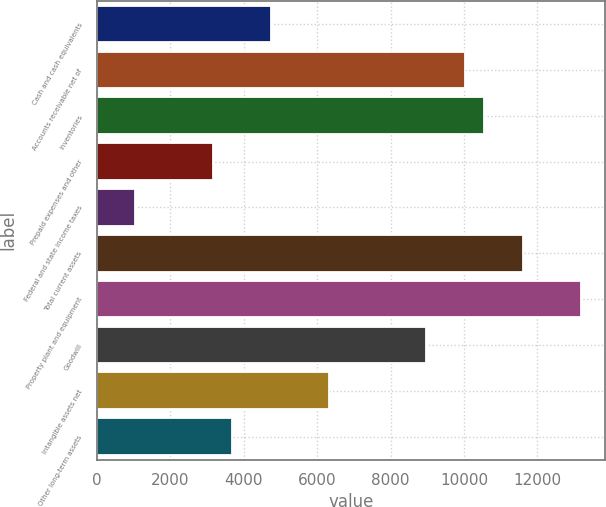Convert chart. <chart><loc_0><loc_0><loc_500><loc_500><bar_chart><fcel>Cash and cash equivalents<fcel>Accounts receivable net of<fcel>Inventories<fcel>Prepaid expenses and other<fcel>Federal and state income taxes<fcel>Total current assets<fcel>Property plant and equipment<fcel>Goodwill<fcel>Intangible assets net<fcel>Other long-term assets<nl><fcel>4745.62<fcel>10017.4<fcel>10544.6<fcel>3164.08<fcel>1055.36<fcel>11599<fcel>13180.5<fcel>8963.06<fcel>6327.16<fcel>3691.26<nl></chart> 